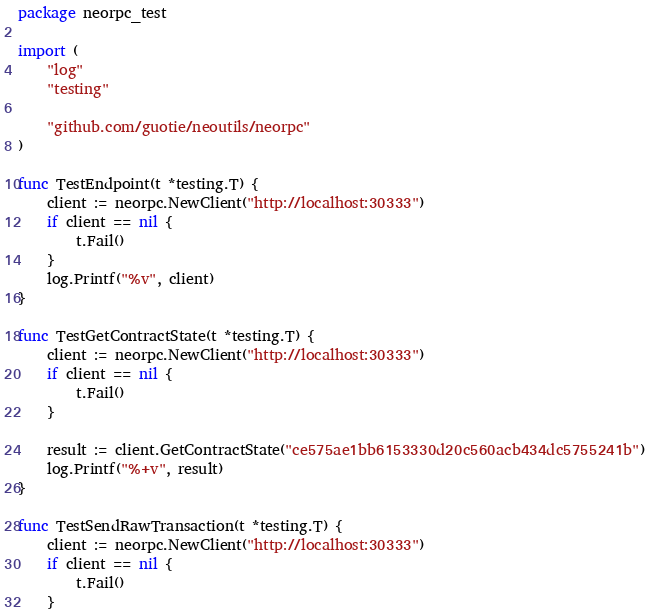Convert code to text. <code><loc_0><loc_0><loc_500><loc_500><_Go_>package neorpc_test

import (
	"log"
	"testing"

	"github.com/guotie/neoutils/neorpc"
)

func TestEndpoint(t *testing.T) {
	client := neorpc.NewClient("http://localhost:30333")
	if client == nil {
		t.Fail()
	}
	log.Printf("%v", client)
}

func TestGetContractState(t *testing.T) {
	client := neorpc.NewClient("http://localhost:30333")
	if client == nil {
		t.Fail()
	}

	result := client.GetContractState("ce575ae1bb6153330d20c560acb434dc5755241b")
	log.Printf("%+v", result)
}

func TestSendRawTransaction(t *testing.T) {
	client := neorpc.NewClient("http://localhost:30333")
	if client == nil {
		t.Fail()
	}</code> 